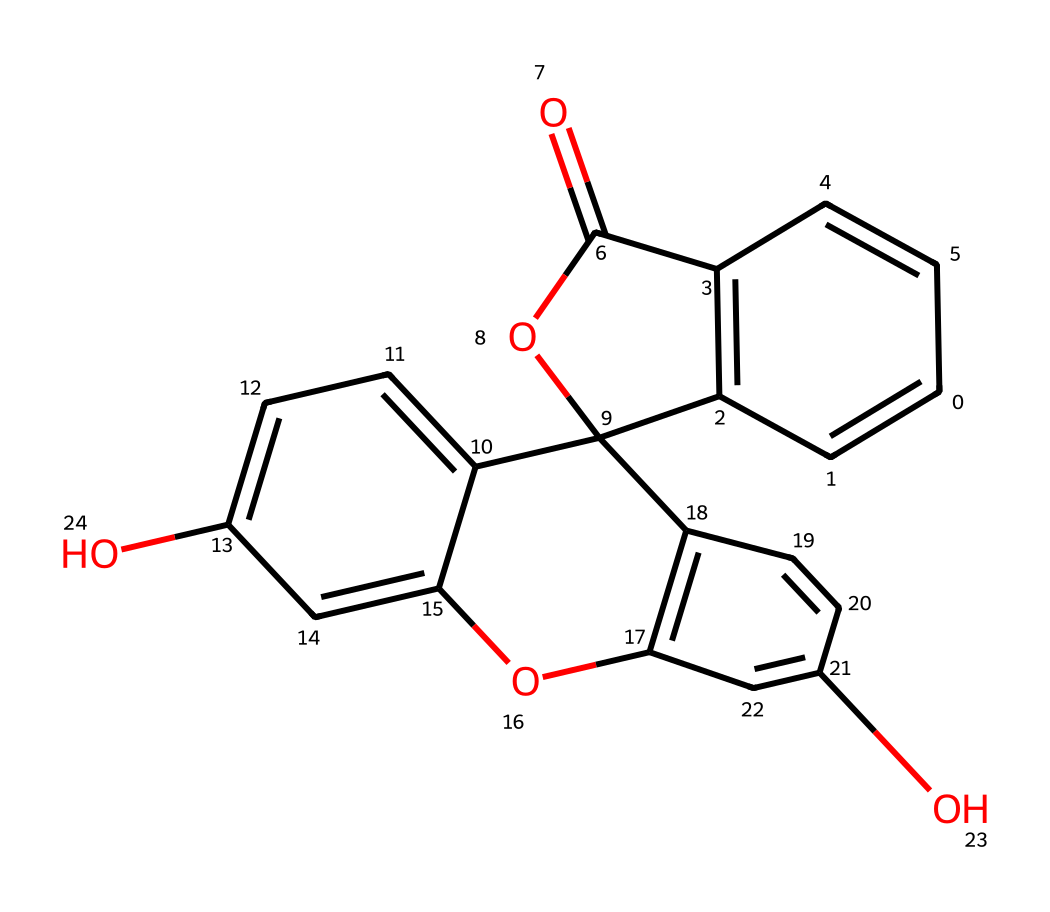What is the total number of carbon atoms in this compound? To determine the total number of carbon atoms, I will examine the SMILES representation. Counting the 'C' symbols plus those in the cyclic structures, I find there are 18 carbon atoms in total.
Answer: 18 How many hydroxyl (OH) groups are present in this molecule? I look for the presence of 'O' atoms that are not part of a carbonyl or ether, indicating hydroxyl groups. The SMILES shows two distinct 'O' atoms, both of which are connected to 'C' atoms suggesting hydroxyl functional groups. Thus, there are two hydroxyl groups.
Answer: 2 Does this compound possess any aromatic rings? I check the presence of alternating single and double bonds in a hexagonal arrangement, which is characteristic of aromatic structures. The chemical structure includes multiple connected rings, confirming that it contains aromatic systems due to these alternating bonds.
Answer: yes What is the primary functional group identified in this compound? I analyze the structure and identify the functional groups present. The compound features an ester link, characterized by 'C(=O)O', denoting an ester functional group.
Answer: ester Which elements other than carbon and hydrogen are represented in this chemical? I scan the SMILES for any symbols besides 'C' and 'H'. The other elements identified are 'O', confirming that oxygen is present in the structure. There are no other elements indicated.
Answer: oxygen What type of chemical reaction might this dye undergo? Considering the functional groups present, particularly the ester group can undergo hydrolysis. Thus, the compound may predominantly participate in hydrolytic reactions where the ester bond can break down in the presence of water.
Answer: hydrolysis 